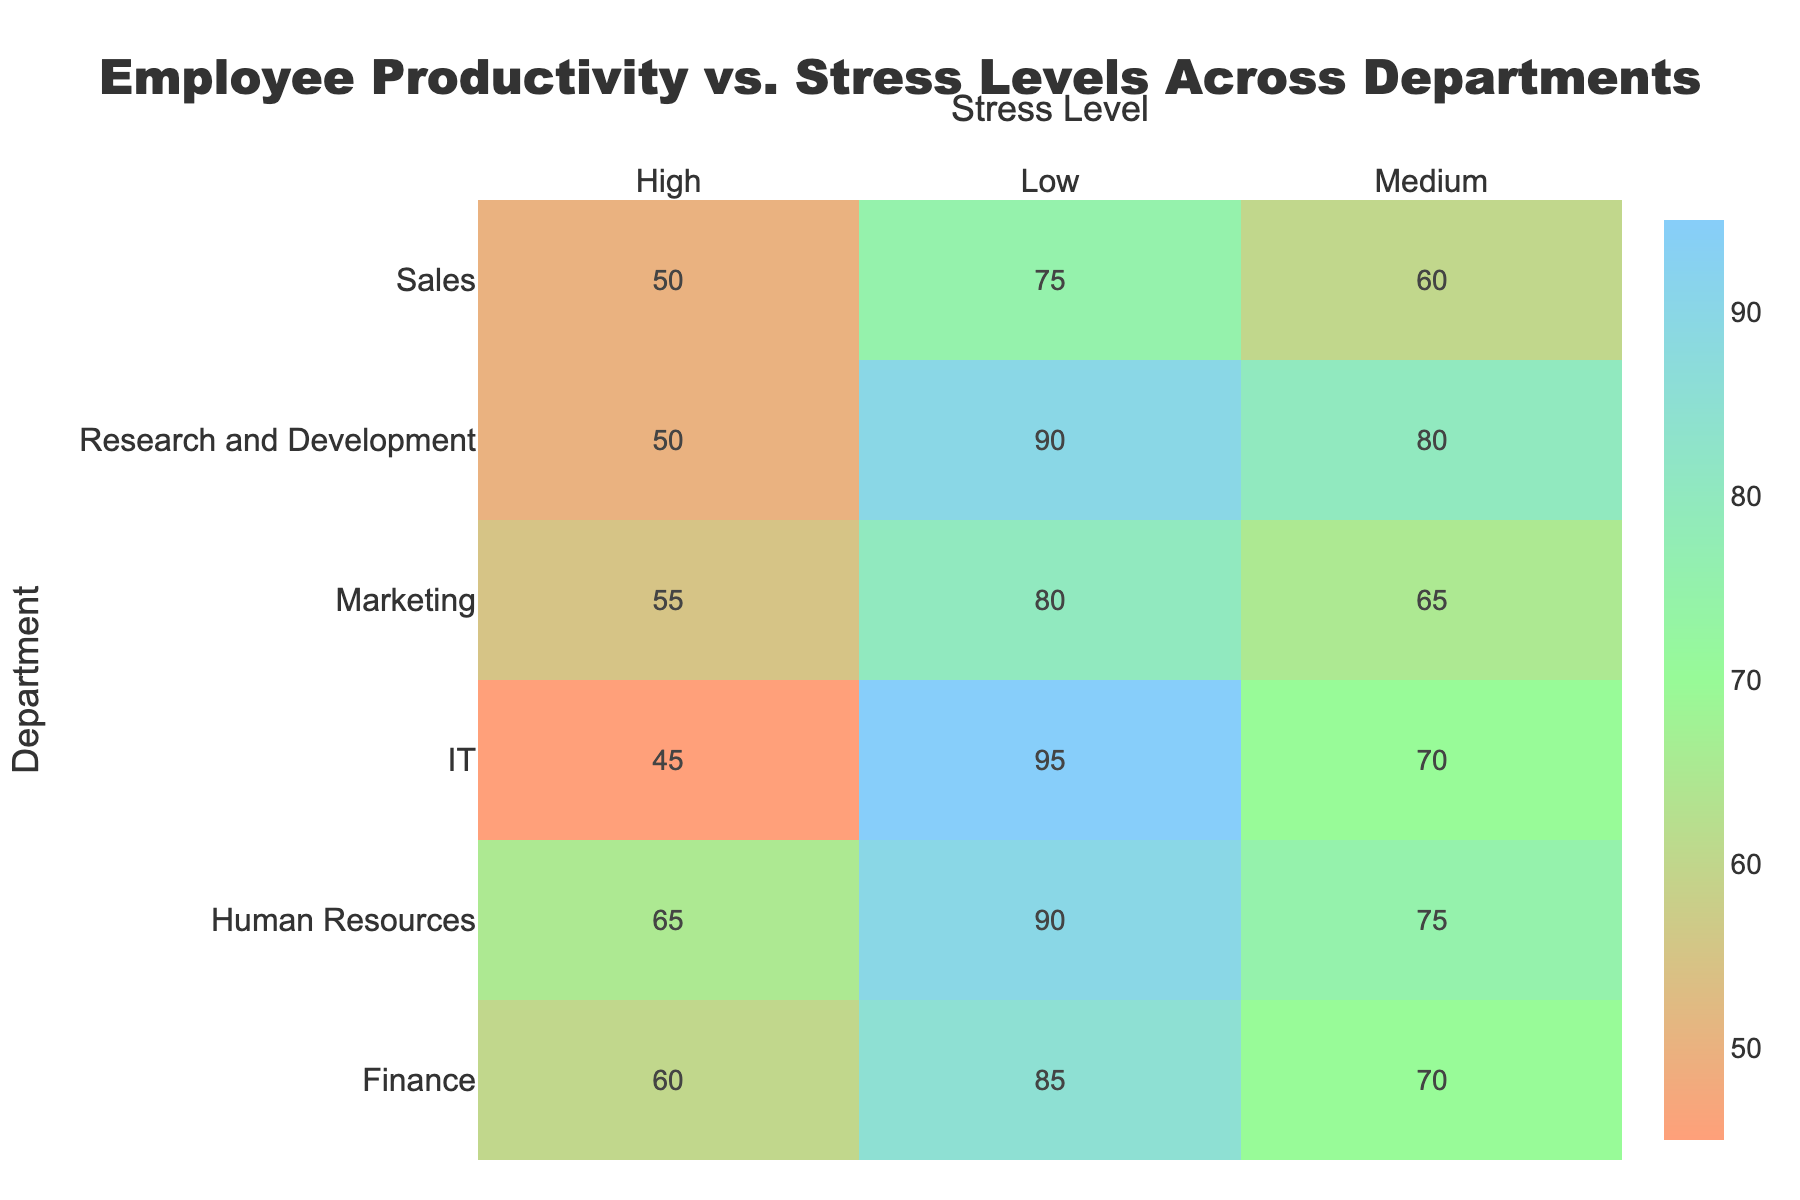How many stress levels are represented in the heatmap? The heatmap has three columns, each representing a different stress level.
Answer: 3 Which department shows the highest productivity under low stress levels? According to the heatmap, IT department has the highest productivity under low stress levels, which is 95.
Answer: IT What is the difference in productivity between high and low stress levels in the Marketing department? In the heatmap, the productivity for Marketing under high stress is 55, and under low stress is 80. The difference is 80 - 55.
Answer: 25 Which department has the lowest productivity under high stress levels? By examining the heatmap, IT department shows the lowest productivity under high stress levels, which is 45.
Answer: IT In the Human Resources department, how does productivity change as the stress level moves from high to low? For the Human Resources department, productivity is 65 under high stress, 75 under medium stress, and 90 under low stress, showing an increase from high to low stress.
Answer: Increases What is the average productivity for the Sales department across all stress levels? The productivity values for the Sales department are 50 (high stress), 60 (medium stress), and 75 (low stress). The average is (50 + 60 + 75) / 3.
Answer: 61.67 Is there any department where productivity under medium stress is higher than under low stress? Scanning through the heatmap, no department shows higher productivity under medium stress compared to low stress.
Answer: No Which stress level has the most consistent productivity values across all departments? By looking at the range of productivity values for each stress level, 'Medium' stress level shows close ranges across all departments: Finance (70), HR (75), Marketing (65), Sales (60), IT (70), R&D (80), indicating medium consistency.
Answer: Medium What is the range of productivity values for the Finance department across different stress levels? The productivity values for Finance are 60 (high stress), 70 (medium stress), and 85 (low stress). The range is 85 - 60.
Answer: 25 